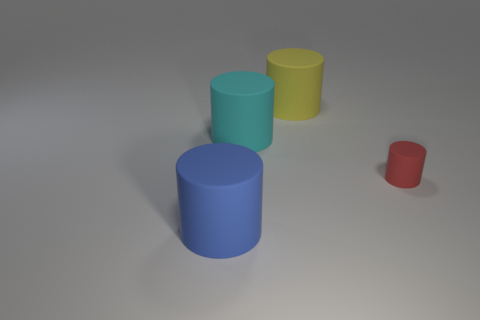The rubber thing that is behind the cyan matte cylinder on the left side of the small cylinder is what color?
Provide a short and direct response. Yellow. The large object behind the big cyan cylinder behind the cylinder right of the yellow cylinder is what shape?
Give a very brief answer. Cylinder. What is the size of the rubber cylinder that is both on the right side of the big cyan rubber thing and on the left side of the small red matte cylinder?
Your answer should be very brief. Large. What number of cylinders are the same color as the tiny matte object?
Your answer should be compact. 0. What is the tiny object made of?
Ensure brevity in your answer.  Rubber. Are the cylinder in front of the tiny red rubber cylinder and the big cyan cylinder made of the same material?
Ensure brevity in your answer.  Yes. What shape is the big rubber thing in front of the tiny red matte thing?
Your answer should be very brief. Cylinder. There is a cyan object that is the same size as the blue object; what is its material?
Your answer should be very brief. Rubber. What number of objects are either large yellow cylinders left of the red rubber thing or cylinders that are on the right side of the big blue matte cylinder?
Provide a succinct answer. 3. There is a yellow cylinder that is made of the same material as the small red object; what size is it?
Make the answer very short. Large. 